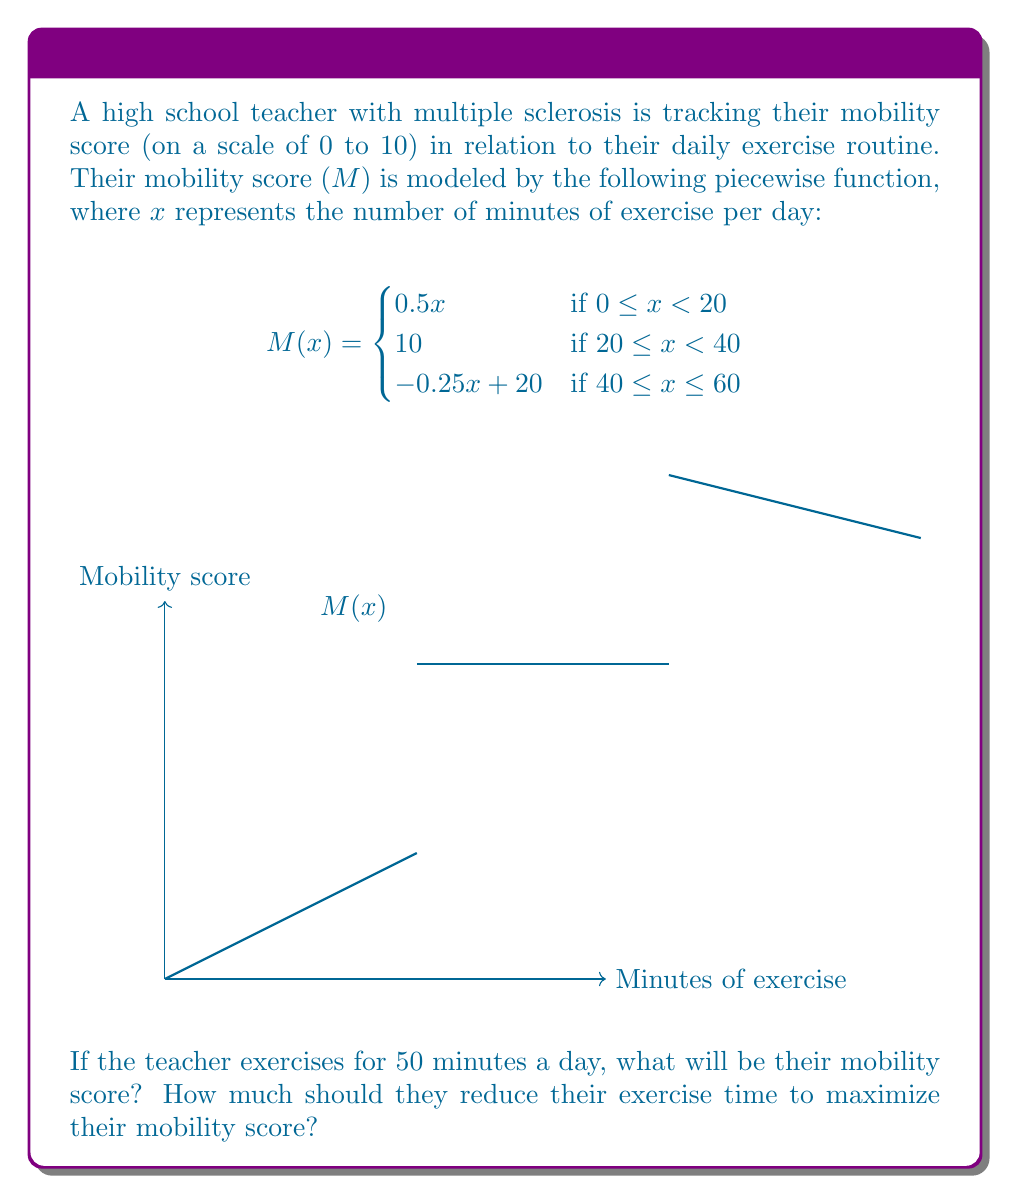Teach me how to tackle this problem. Let's approach this problem step-by-step:

1) First, we need to determine which piece of the function applies when x = 50 minutes.
   Since 50 is in the range 40 ≤ x ≤ 60, we use the third piece of the function:
   $M(x) = -0.25x + 20$

2) Now, let's calculate the mobility score for 50 minutes of exercise:
   $M(50) = -0.25(50) + 20$
   $= -12.5 + 20$
   $= 7.5$

3) To find the exercise time that maximizes the mobility score, we need to look at the function:
   - For 0 ≤ x < 20, the score increases linearly.
   - For 20 ≤ x < 40, the score is constant at 10 (the maximum).
   - For 40 ≤ x ≤ 60, the score decreases linearly.

4) Therefore, to maximize the mobility score, the teacher should exercise for any duration between 20 and 40 minutes.

5) To find how much they should reduce their exercise time:
   Current exercise time: 50 minutes
   Maximum score exercise time: 40 minutes (the lower bound of the maximum range)
   Reduction needed: 50 - 40 = 10 minutes
Answer: Mobility score at 50 minutes: 7.5. Reduce exercise by 10 minutes to maximize score. 